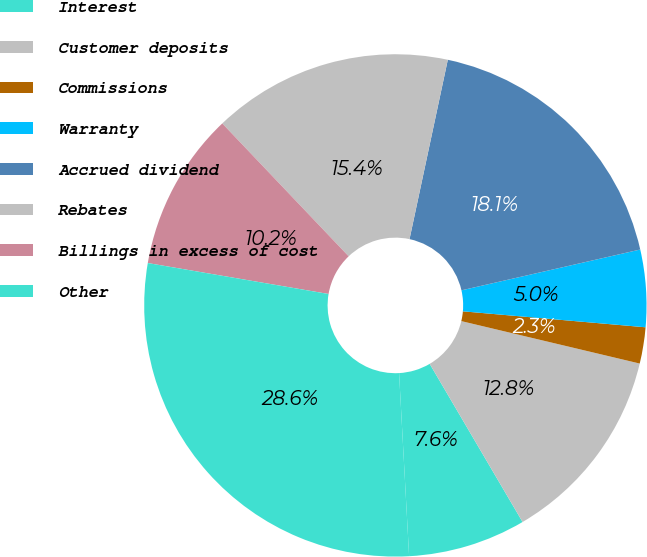Convert chart to OTSL. <chart><loc_0><loc_0><loc_500><loc_500><pie_chart><fcel>Interest<fcel>Customer deposits<fcel>Commissions<fcel>Warranty<fcel>Accrued dividend<fcel>Rebates<fcel>Billings in excess of cost<fcel>Other<nl><fcel>7.58%<fcel>12.83%<fcel>2.33%<fcel>4.96%<fcel>18.08%<fcel>15.45%<fcel>10.2%<fcel>28.57%<nl></chart> 